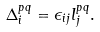Convert formula to latex. <formula><loc_0><loc_0><loc_500><loc_500>\Delta _ { i } ^ { p q } = \epsilon _ { i j } l _ { j } ^ { p q } .</formula> 